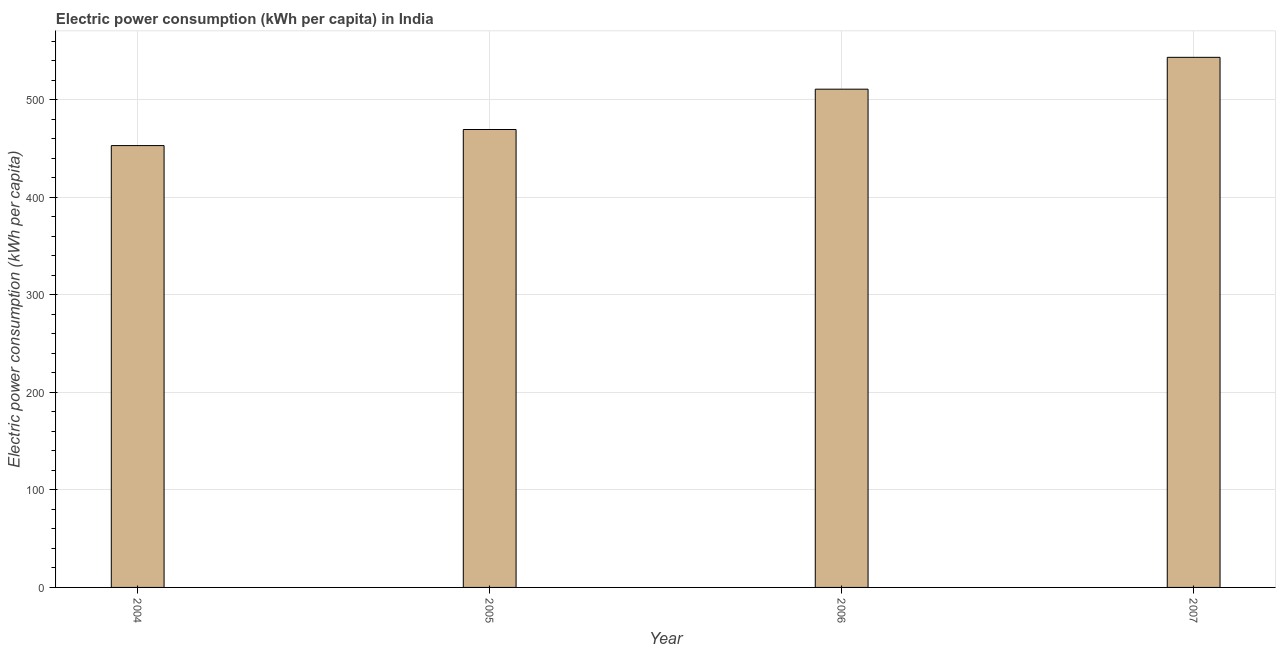What is the title of the graph?
Offer a terse response. Electric power consumption (kWh per capita) in India. What is the label or title of the Y-axis?
Make the answer very short. Electric power consumption (kWh per capita). What is the electric power consumption in 2006?
Give a very brief answer. 510.7. Across all years, what is the maximum electric power consumption?
Offer a terse response. 543.36. Across all years, what is the minimum electric power consumption?
Ensure brevity in your answer.  452.9. In which year was the electric power consumption minimum?
Ensure brevity in your answer.  2004. What is the sum of the electric power consumption?
Provide a short and direct response. 1976.32. What is the difference between the electric power consumption in 2005 and 2007?
Give a very brief answer. -73.99. What is the average electric power consumption per year?
Provide a short and direct response. 494.08. What is the median electric power consumption?
Your answer should be very brief. 490.04. Do a majority of the years between 2006 and 2007 (inclusive) have electric power consumption greater than 500 kWh per capita?
Give a very brief answer. Yes. What is the ratio of the electric power consumption in 2005 to that in 2007?
Offer a very short reply. 0.86. Is the electric power consumption in 2005 less than that in 2007?
Your answer should be compact. Yes. What is the difference between the highest and the second highest electric power consumption?
Provide a succinct answer. 32.65. Is the sum of the electric power consumption in 2004 and 2005 greater than the maximum electric power consumption across all years?
Give a very brief answer. Yes. What is the difference between the highest and the lowest electric power consumption?
Offer a very short reply. 90.46. In how many years, is the electric power consumption greater than the average electric power consumption taken over all years?
Your response must be concise. 2. How many years are there in the graph?
Make the answer very short. 4. What is the difference between two consecutive major ticks on the Y-axis?
Your answer should be compact. 100. Are the values on the major ticks of Y-axis written in scientific E-notation?
Give a very brief answer. No. What is the Electric power consumption (kWh per capita) of 2004?
Your answer should be compact. 452.9. What is the Electric power consumption (kWh per capita) in 2005?
Keep it short and to the point. 469.37. What is the Electric power consumption (kWh per capita) of 2006?
Offer a terse response. 510.7. What is the Electric power consumption (kWh per capita) of 2007?
Your answer should be compact. 543.36. What is the difference between the Electric power consumption (kWh per capita) in 2004 and 2005?
Keep it short and to the point. -16.47. What is the difference between the Electric power consumption (kWh per capita) in 2004 and 2006?
Provide a succinct answer. -57.81. What is the difference between the Electric power consumption (kWh per capita) in 2004 and 2007?
Provide a short and direct response. -90.46. What is the difference between the Electric power consumption (kWh per capita) in 2005 and 2006?
Provide a short and direct response. -41.33. What is the difference between the Electric power consumption (kWh per capita) in 2005 and 2007?
Your answer should be compact. -73.99. What is the difference between the Electric power consumption (kWh per capita) in 2006 and 2007?
Provide a succinct answer. -32.65. What is the ratio of the Electric power consumption (kWh per capita) in 2004 to that in 2006?
Offer a terse response. 0.89. What is the ratio of the Electric power consumption (kWh per capita) in 2004 to that in 2007?
Your response must be concise. 0.83. What is the ratio of the Electric power consumption (kWh per capita) in 2005 to that in 2006?
Your answer should be compact. 0.92. What is the ratio of the Electric power consumption (kWh per capita) in 2005 to that in 2007?
Ensure brevity in your answer.  0.86. What is the ratio of the Electric power consumption (kWh per capita) in 2006 to that in 2007?
Your response must be concise. 0.94. 